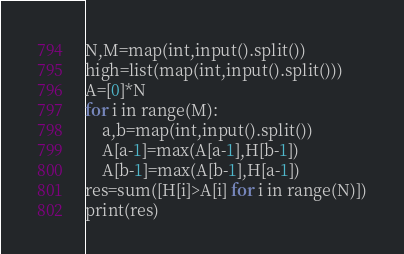Convert code to text. <code><loc_0><loc_0><loc_500><loc_500><_Python_>N,M=map(int,input().split())
high=list(map(int,input().split()))
A=[0]*N
for i in range(M):
    a,b=map(int,input().split())
    A[a-1]=max(A[a-1],H[b-1])
    A[b-1]=max(A[b-1],H[a-1])
res=sum([H[i]>A[i] for i in range(N)])
print(res)
</code> 